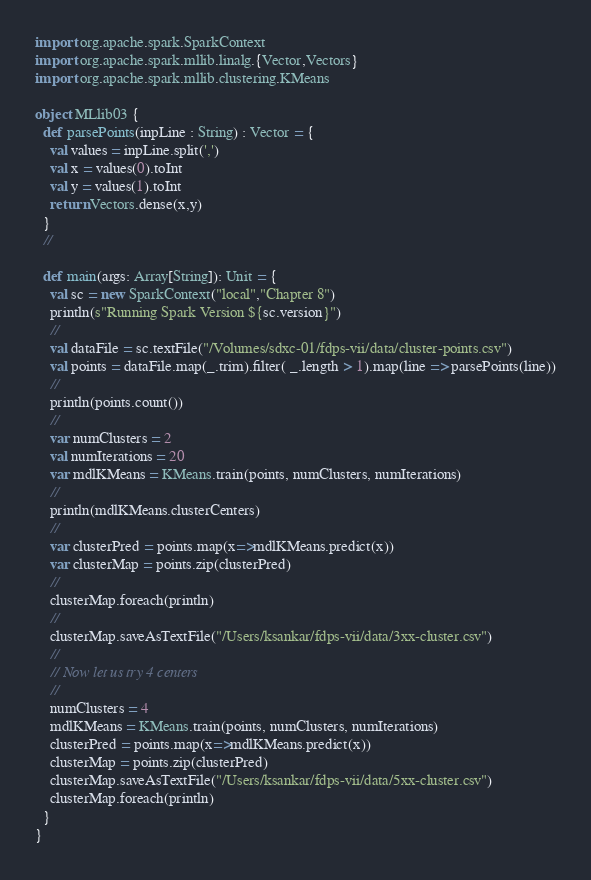Convert code to text. <code><loc_0><loc_0><loc_500><loc_500><_Scala_>import org.apache.spark.SparkContext
import org.apache.spark.mllib.linalg.{Vector,Vectors}
import org.apache.spark.mllib.clustering.KMeans

object MLlib03 {
  def parsePoints(inpLine : String) : Vector = {
    val values = inpLine.split(',')
    val x = values(0).toInt
    val y = values(1).toInt
    return Vectors.dense(x,y)
  }
  //

  def main(args: Array[String]): Unit = {
    val sc = new SparkContext("local","Chapter 8")
    println(s"Running Spark Version ${sc.version}")
    //
    val dataFile = sc.textFile("/Volumes/sdxc-01/fdps-vii/data/cluster-points.csv")
    val points = dataFile.map(_.trim).filter( _.length > 1).map(line => parsePoints(line))
    //
    println(points.count())
    //
    var numClusters = 2
    val numIterations = 20
    var mdlKMeans = KMeans.train(points, numClusters, numIterations)
    //
    println(mdlKMeans.clusterCenters)
    //
    var clusterPred = points.map(x=>mdlKMeans.predict(x))
    var clusterMap = points.zip(clusterPred)
    //
    clusterMap.foreach(println)
    //
    clusterMap.saveAsTextFile("/Users/ksankar/fdps-vii/data/3xx-cluster.csv")
    //
    // Now let us try 4 centers
    //
    numClusters = 4
    mdlKMeans = KMeans.train(points, numClusters, numIterations)
    clusterPred = points.map(x=>mdlKMeans.predict(x))
    clusterMap = points.zip(clusterPred)
    clusterMap.saveAsTextFile("/Users/ksankar/fdps-vii/data/5xx-cluster.csv")
    clusterMap.foreach(println)
  }
}</code> 